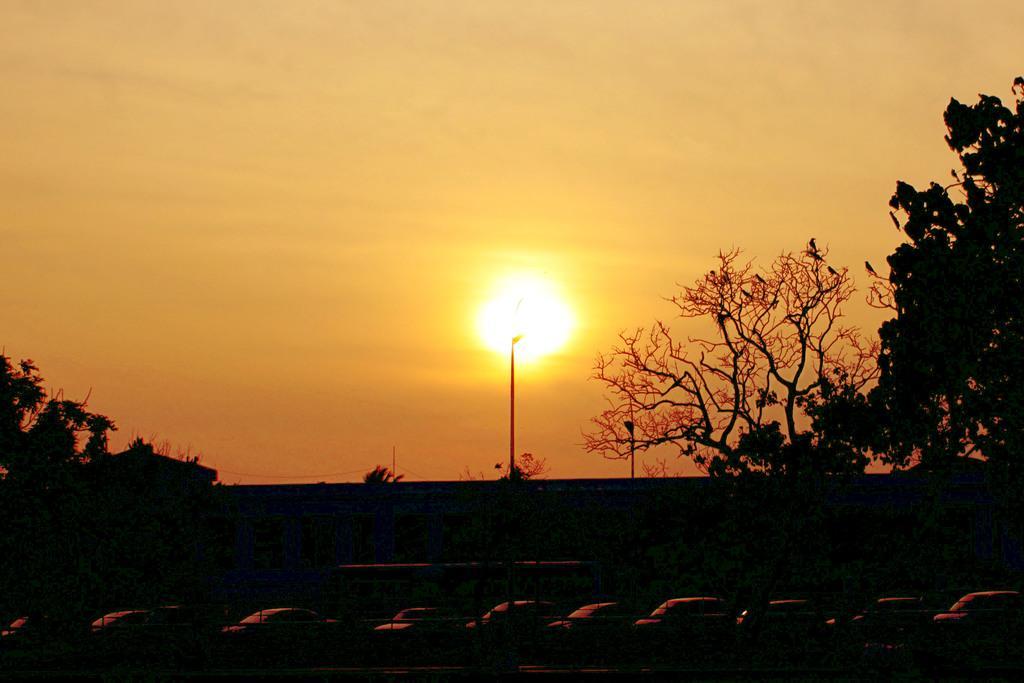How would you summarize this image in a sentence or two? In the background we can see the sky and the sun. In this picture we can see the light poles, trees, birds. Bottom portion of the picture is dark. We can see the wall, railing and the vehicles. 